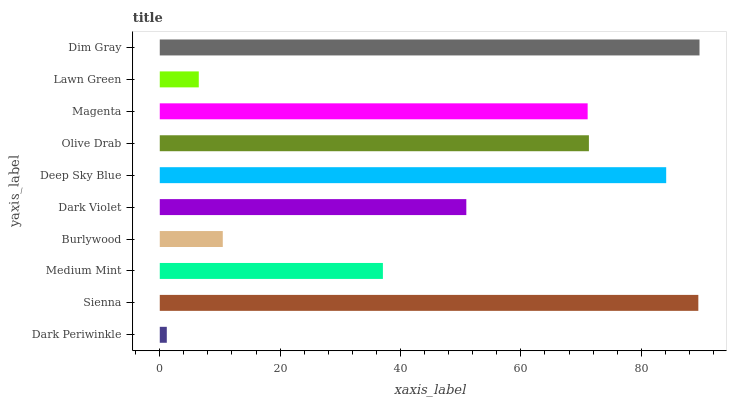Is Dark Periwinkle the minimum?
Answer yes or no. Yes. Is Dim Gray the maximum?
Answer yes or no. Yes. Is Sienna the minimum?
Answer yes or no. No. Is Sienna the maximum?
Answer yes or no. No. Is Sienna greater than Dark Periwinkle?
Answer yes or no. Yes. Is Dark Periwinkle less than Sienna?
Answer yes or no. Yes. Is Dark Periwinkle greater than Sienna?
Answer yes or no. No. Is Sienna less than Dark Periwinkle?
Answer yes or no. No. Is Magenta the high median?
Answer yes or no. Yes. Is Dark Violet the low median?
Answer yes or no. Yes. Is Olive Drab the high median?
Answer yes or no. No. Is Deep Sky Blue the low median?
Answer yes or no. No. 